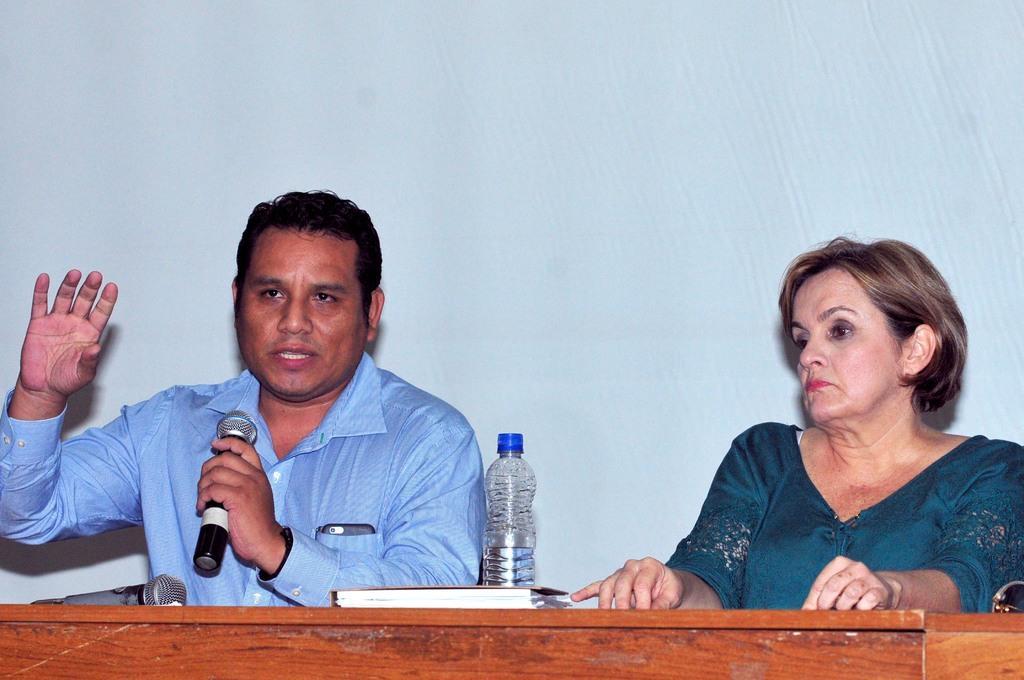Could you give a brief overview of what you see in this image? In the background we can see the wall. In this picture we can see a man and a woman sitting. We can see a man holding a microphone and talking. On a wooden table we can see a microphone, diary, water bottle and goggles. 